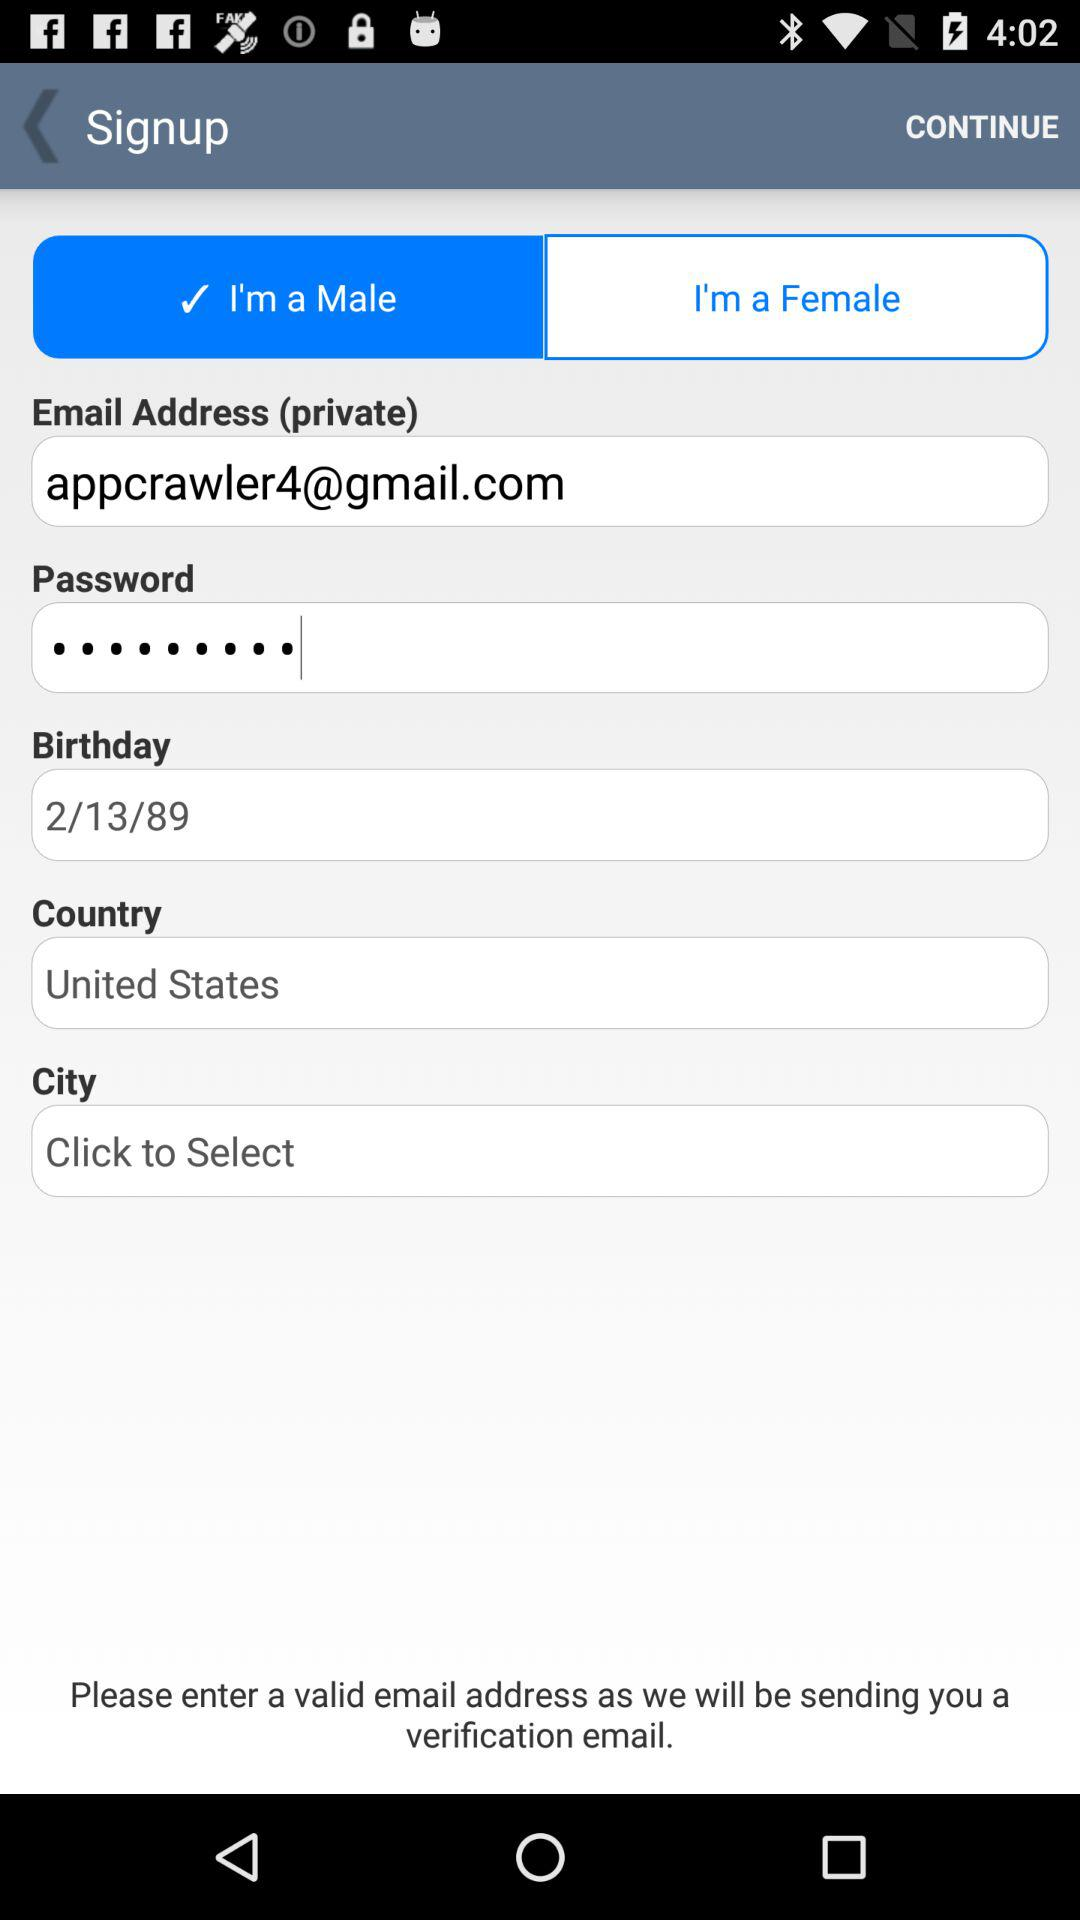What's the Gmail address used by the user to sign up? The Gmail address is appcrawler4@gmail.com. 